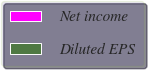Convert chart. <chart><loc_0><loc_0><loc_500><loc_500><pie_chart><fcel>Net income<fcel>Diluted EPS<nl><fcel>100.0%<fcel>0.0%<nl></chart> 